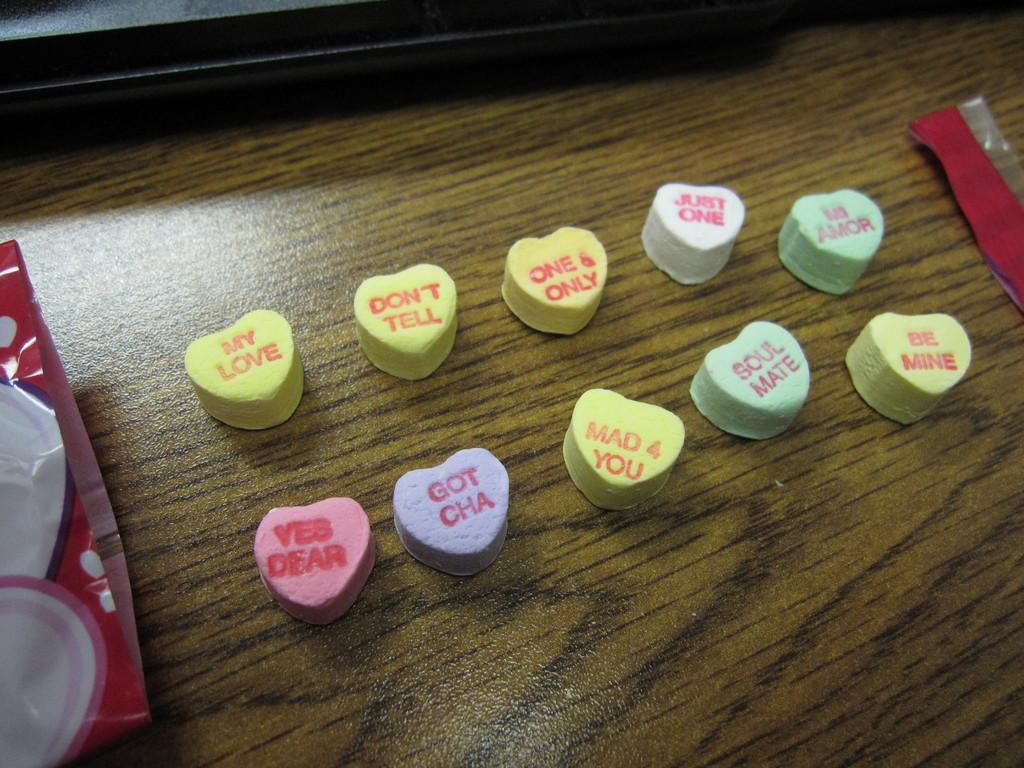Please provide a concise description of this image. In the image there are heart shaped candies on a wooden table with a cover beside it on the left side. 